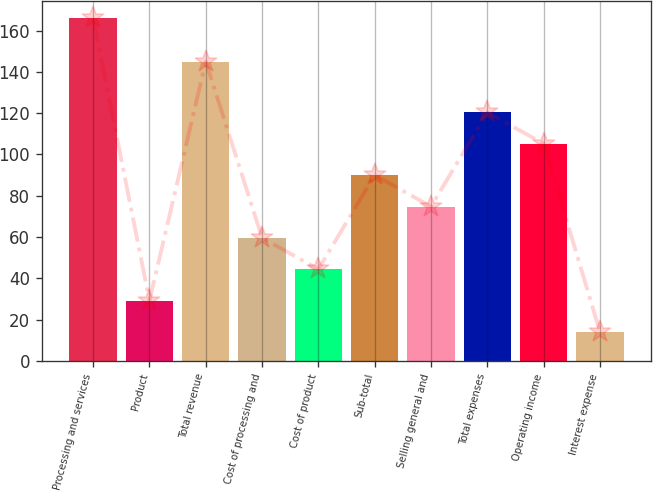<chart> <loc_0><loc_0><loc_500><loc_500><bar_chart><fcel>Processing and services<fcel>Product<fcel>Total revenue<fcel>Cost of processing and<fcel>Cost of product<fcel>Sub-total<fcel>Selling general and<fcel>Total expenses<fcel>Operating income<fcel>Interest expense<nl><fcel>166<fcel>29.2<fcel>145<fcel>59.6<fcel>44.4<fcel>90<fcel>74.8<fcel>120.4<fcel>105.2<fcel>14<nl></chart> 